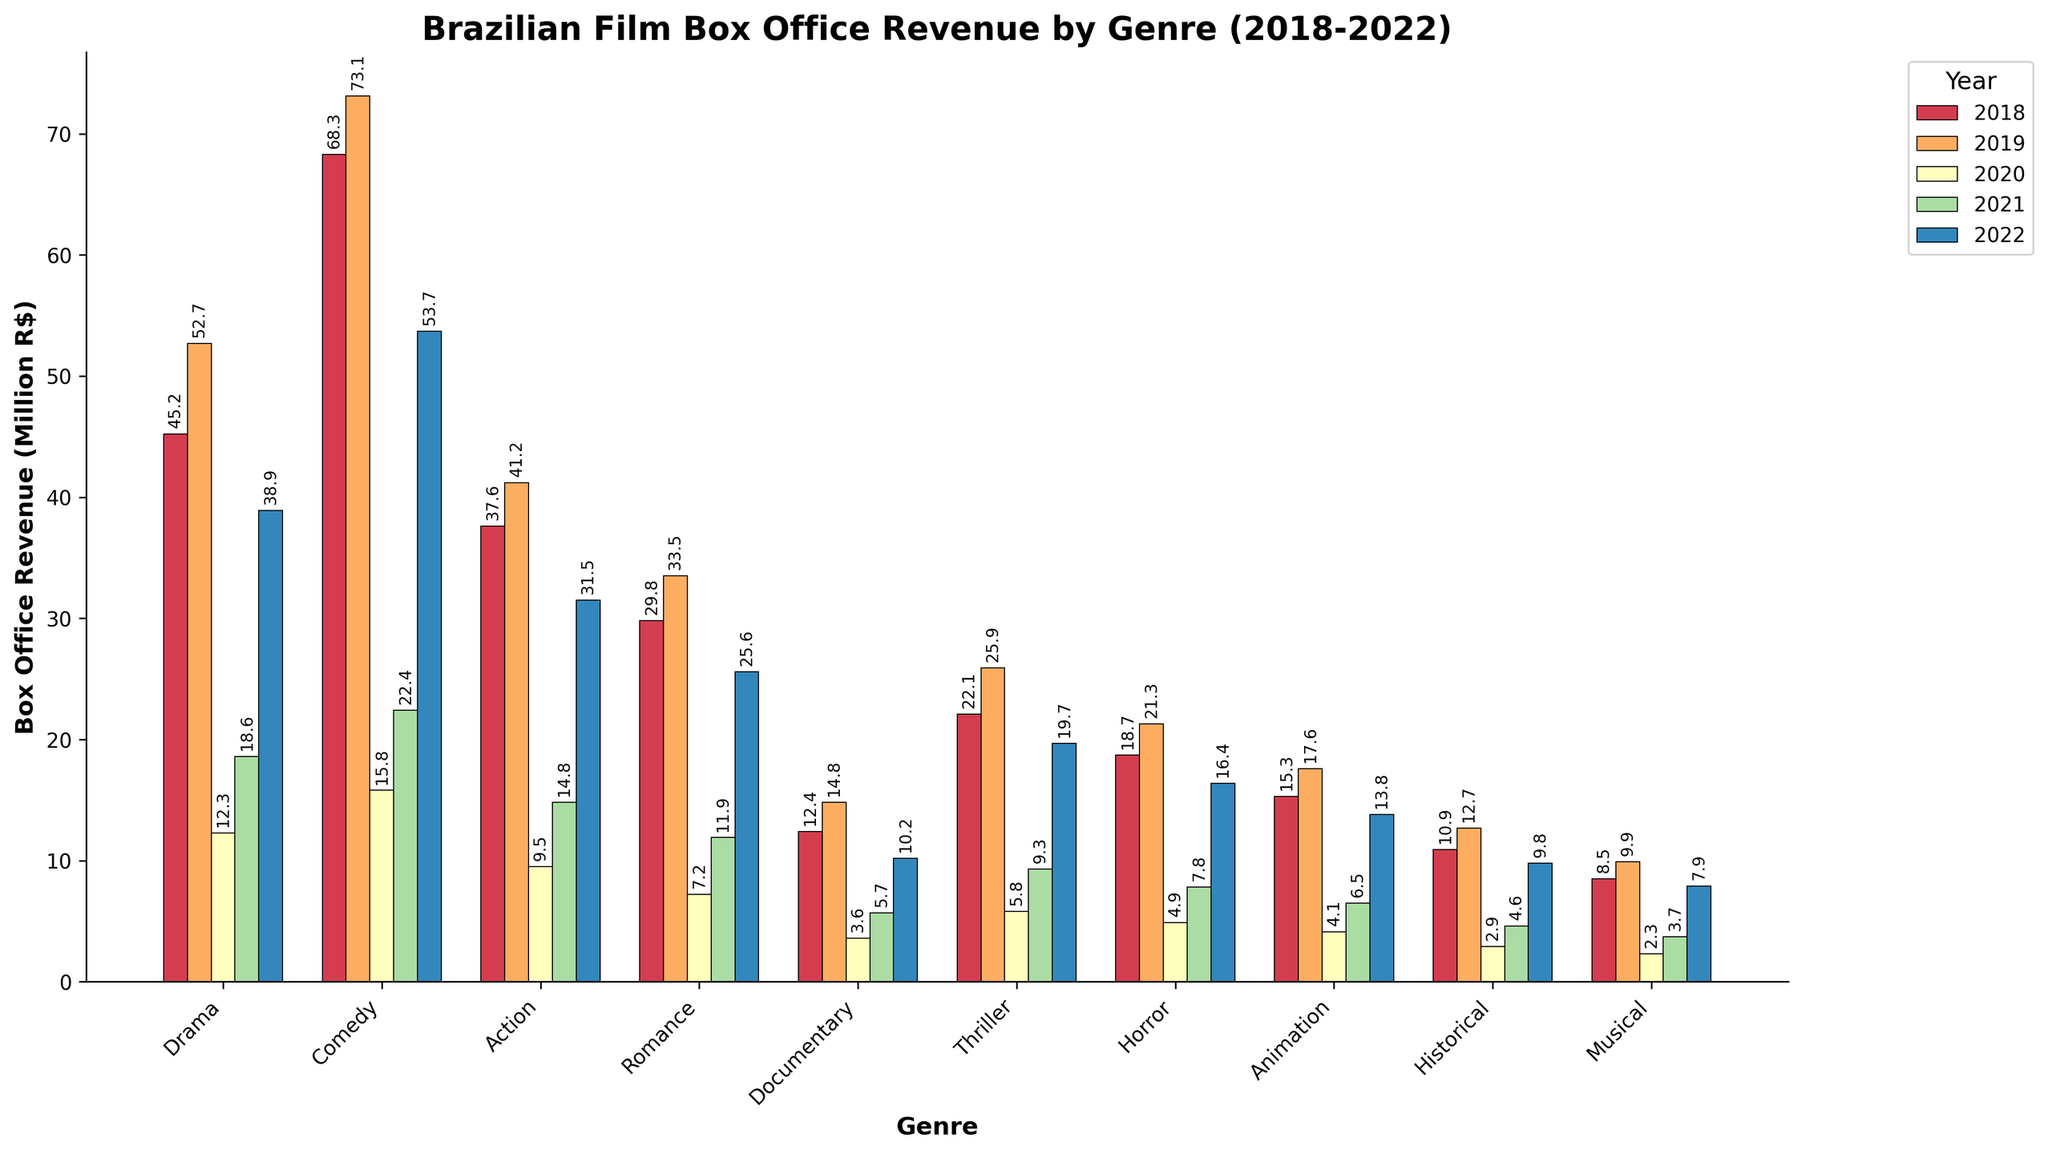What was the highest box office revenue for the Comedy genre over the past 5 years? The highest box office revenue for the Comedy genre occurred in 2019. By comparing the values for each year (68.3, 73.1, 15.8, 22.4, 53.7), we see that 73.1 million R$ is the highest.
Answer: 73.1 million R$ Which genre had the lowest box office revenue in 2021? By comparing the box office revenues for all genres in 2021, the Musical genre had the lowest value at 3.7 million R$.
Answer: Musical How does the box office revenue for Historical genre in 2022 compare to Documentary genre in 2020? In 2022, the Historical genre had a box office revenue of 9.8 million R$, while in 2020, the Documentary genre had a revenue of 3.6 million R$. Comparing these, 9.8 is greater than 3.6.
Answer: Higher Which year did the Action genre witness the lowest box office revenue, and what was the figure? By examining the Action genre's box office revenue across the years (37.6, 41.2, 9.5, 14.8, 31.5), 2020 shows the lowest revenue at 9.5 million R$.
Answer: 2020, 9.5 million R$ Calculate the average box office revenue for the Drama genre over the five years. Summing the Drama genre's revenues (45.2 + 52.7 + 12.3 + 18.6 + 38.9) gives us 167.7. Dividing this by 5, we get the average: 167.7 / 5 = 33.54 million R$.
Answer: 33.54 million R$ Which genre experienced the most significant increase in revenue from 2021 to 2022? Calculating the differences for each genre: Drama (38.9-18.6=20.3), Comedy (53.7-22.4=31.3), Action (31.5-14.8=16.7), Romance (25.6-11.9=13.7), Documentary (10.2-5.7=4.5), Thriller (19.7-9.3=10.4), Horror (16.4-7.8=8.6), Animation (13.8-6.5=7.3), Historical (9.8-4.6=5.2), and Musical (7.9-3.7=4.2). Comedy had the biggest increase of 31.3 million R$.
Answer: Comedy By what percentage did the box office revenue for the Horror genre drop from 2019 to 2020? The Horror genre revenue dropped from 21.3 million R$ in 2019 to 4.9 million R$ in 2020. The percentage drop is calculated as ((21.3 - 4.9) / 21.3) * 100 ≈ 76.9%.
Answer: 76.9% Which two genres had the closest box office revenues in 2022, and what were the differences? In 2022, the closest box office revenues are between Horror (16.4) and Thriller (19.7) with a difference of 19.7 - 16.4 = 3.3 million R$.
Answer: Horror and Thriller, 3.3 million R$ What was the total box office revenue for all genres combined in 2020? Adding each genre's revenue for 2020: 12.3 (Drama) + 15.8 (Comedy) + 9.5 (Action) + 7.2 (Romance) + 3.6 (Documentary) + 5.8 (Thriller) + 4.9 (Horror) + 4.1 (Animation) + 2.9 (Historical) + 2.3 (Musical) gives 68.4 million R$.
Answer: 68.4 million R$ Which genre showed the most consistent box office revenue over the five years, and how do we determine consistency? To determine consistency, we look at the variance in the box office revenues. The Documentary genre shows small variations and the lowest variance among others (12.4, 14.8, 3.6, 5.7, 10.2), indicating it is the most consistent.
Answer: Documentary 